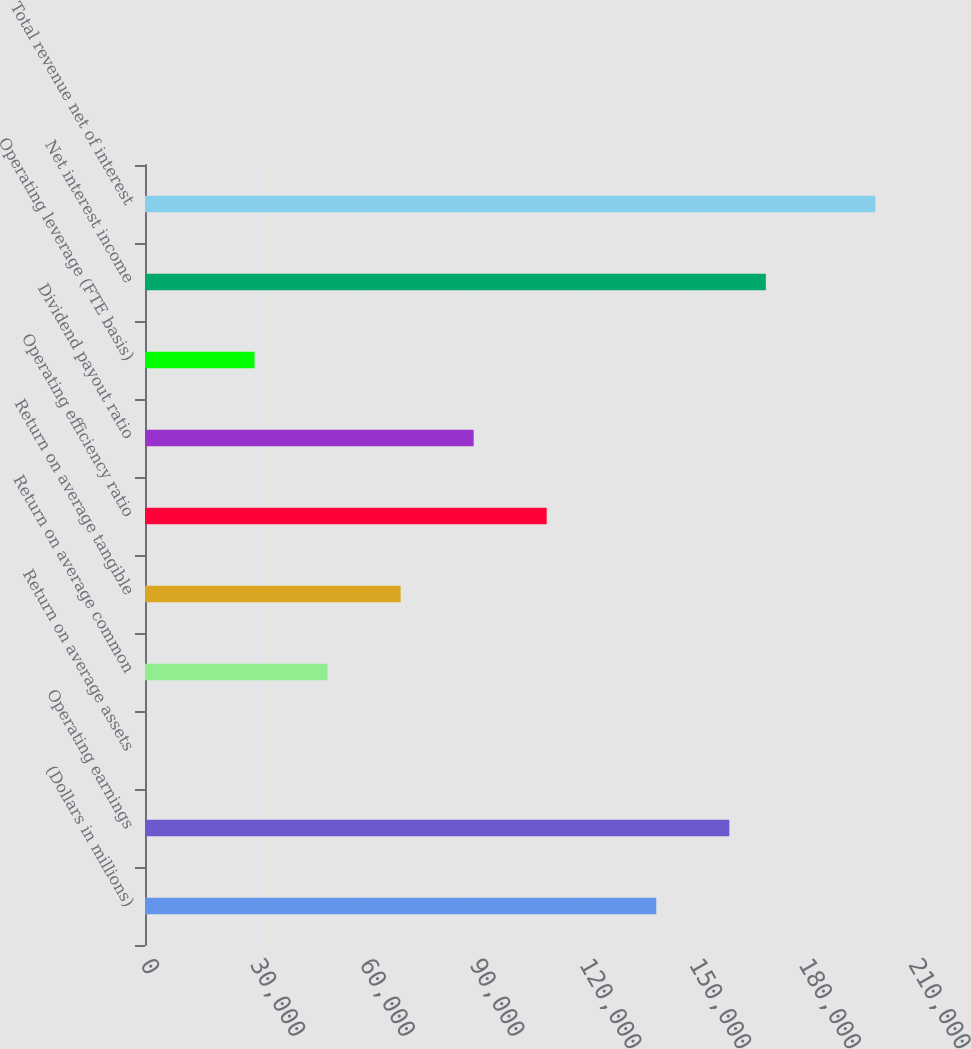<chart> <loc_0><loc_0><loc_500><loc_500><bar_chart><fcel>(Dollars in millions)<fcel>Operating earnings<fcel>Return on average assets<fcel>Return on average common<fcel>Return on average tangible<fcel>Operating efficiency ratio<fcel>Dividend payout ratio<fcel>Operating leverage (FTE basis)<fcel>Net interest income<fcel>Total revenue net of interest<nl><fcel>139805<fcel>159777<fcel>1.32<fcel>49931.2<fcel>69903.1<fcel>109847<fcel>89875.1<fcel>29959.2<fcel>169763<fcel>199721<nl></chart> 